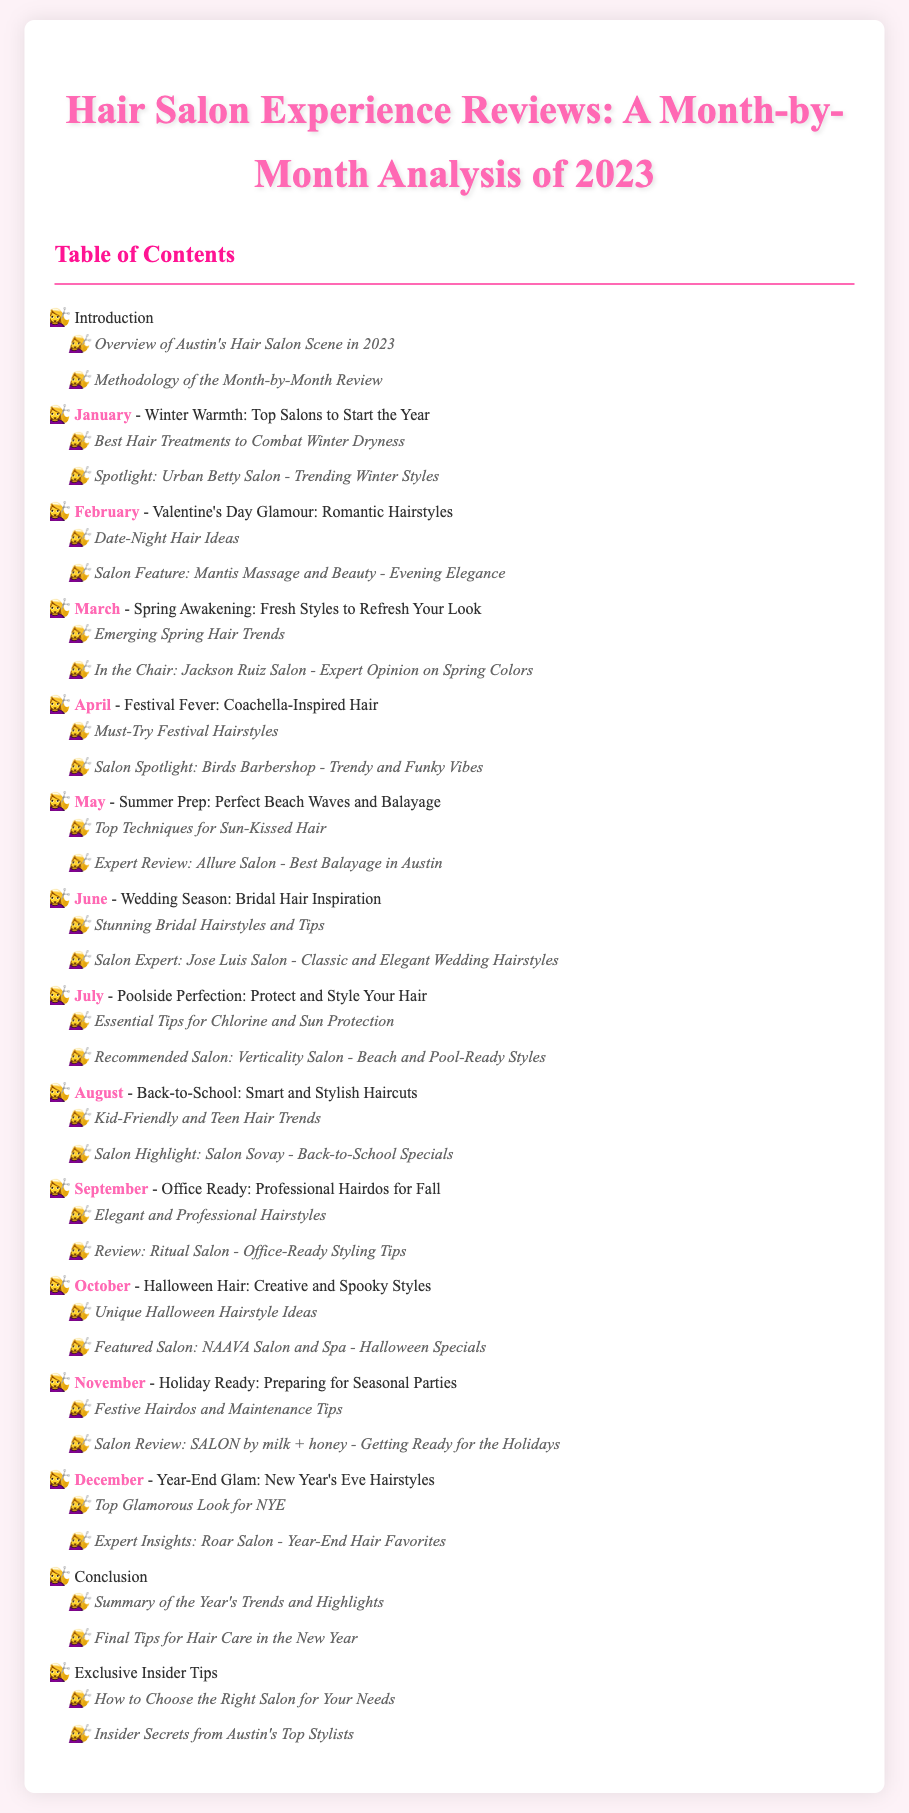What is the title of the document? The title of the document is specified in the header section.
Answer: Hair Salon Experience Reviews: A Month-by-Month Analysis of 2023 How many months are covered in the analysis? The analysis covers one year, meaning it includes all twelve months.
Answer: 12 Which salon is featured in January? The document lists a specific salon highlighted for January under that month's section.
Answer: Urban Betty Salon What is the theme for April? Each month has a specific theme, and April's theme is provided in the description.
Answer: Festival Fever: Coachella-Inspired Hair What type of hairstyles are discussed for June? The document specifies a particular type of hairstyle relevant to June.
Answer: Bridal Hair Inspiration Which month focuses on back-to-school hairstyles? The month mentioned in the document that emphasizes back-to-school styles is highlighted.
Answer: August What is noted as a key hair trend in March? The document mentions central trends relevant to March in its overview.
Answer: Emerging Spring Hair Trends What is the main topic of the conclusion section? The conclusion sums up the overall themes discussed in the document.
Answer: Summary of the Year's Trends and Highlights Which salon is highlighted for recommendations in December? The document lists a particular salon spotlight for December-related themes.
Answer: Roar Salon 